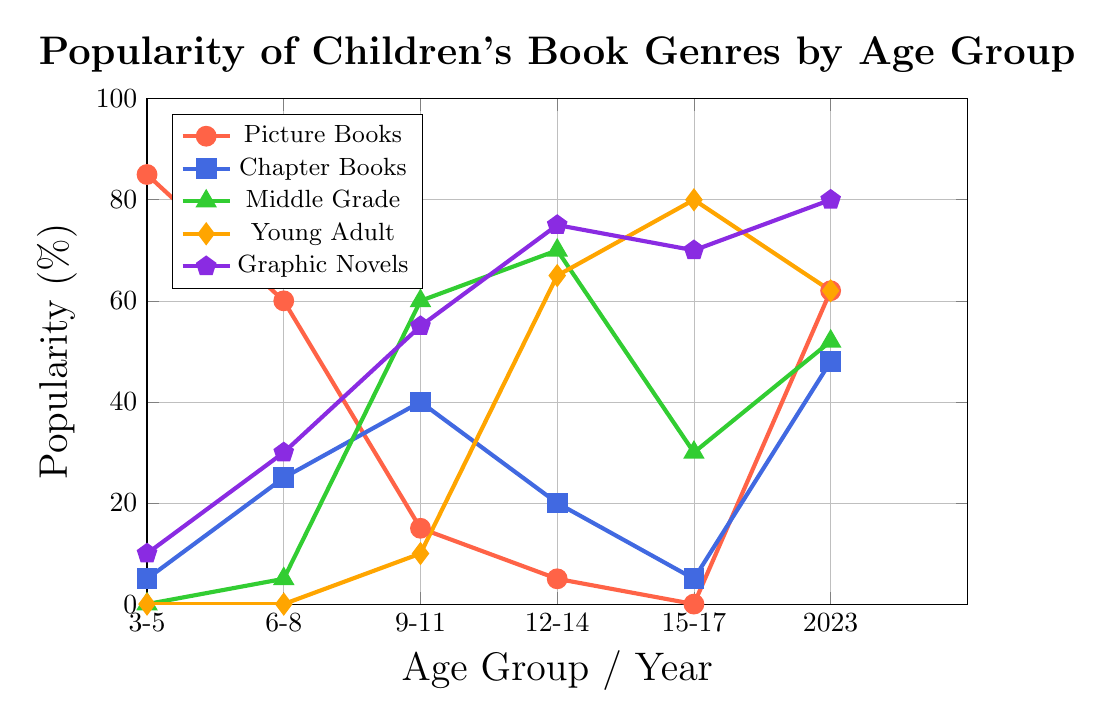How has the popularity of Picture Books changed over time from age group 3-5 to age group 15-17? The popularity of Picture Books starts at 85% in the 3-5 age group, decreases to 60% in the 6-8 age group, and continues to drop sharply to 15%, 5%, and 0% in the 9-11, 12-14, and 15-17 age groups, respectively.
Answer: Decreased Which genre has the highest popularity in the 9-11 age group? Referring to the 9-11 age group, we see Middle Grade with 60% is higher than any other genre in this age group.
Answer: Middle Grade Between Chapter Books and Young Adult genres, which shows a greater increase in popularity from age group 6-8 to 9-11? Chapter Books increase from 25% to 40%, a difference of 15%. Young Adult increases from 0% to 10%, a difference of 10%. Therefore, Chapter Books show a greater increase.
Answer: Chapter Books Which age group shows a higher popularity for Graphic Novels than any other genre? In the 12-14 age group, the Graphic Novels have the highest popularity at 75%, which is higher than any other genre in this age group.
Answer: 12-14 years What is the average popularity of Young Adult books from age group 9-11 to age group 15-17? The values given for Young Adult from ages 9-11 to 15-17 are 10, 65, and 80. Sum these values to get 10 + 65 + 80 = 155. The average is 155/3 = 51.67%.
Answer: 51.67% In which age group or year do Picture Books have exactly 5% popularity? Referring to all age groups and years, Picture Books have exactly 5% popularity in the 6-8 age group and the year 2013.
Answer: 6-8 years, 2013 From 2013 to 2023, which genre shows the highest increase in popularity? Compare the popularity values for 2013 to 2023 for each genre: Picture Books (75 to 62), Chapter Books (35 to 48), Middle Grade (40 to 52), Young Adult (45 to 62), Graphic Novels (25 to 80). The highest increase is seen in Graphic Novels (55%).
Answer: Graphic Novels Which genre appears to be most consistently popular across all age groups? By examining the chart, we see that Graphic Novels retain relatively high and increasing popularity across all age groups, except 3-5 years where they have 10%, but quickly rise again.
Answer: Graphic Novels 